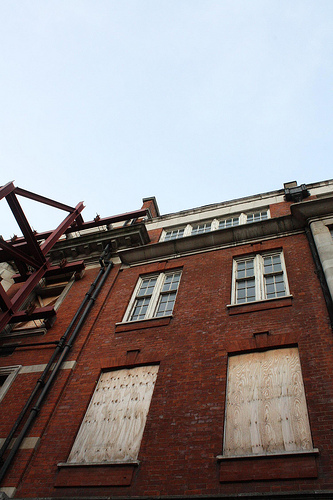<image>
Can you confirm if the window is in front of the building? Yes. The window is positioned in front of the building, appearing closer to the camera viewpoint. 